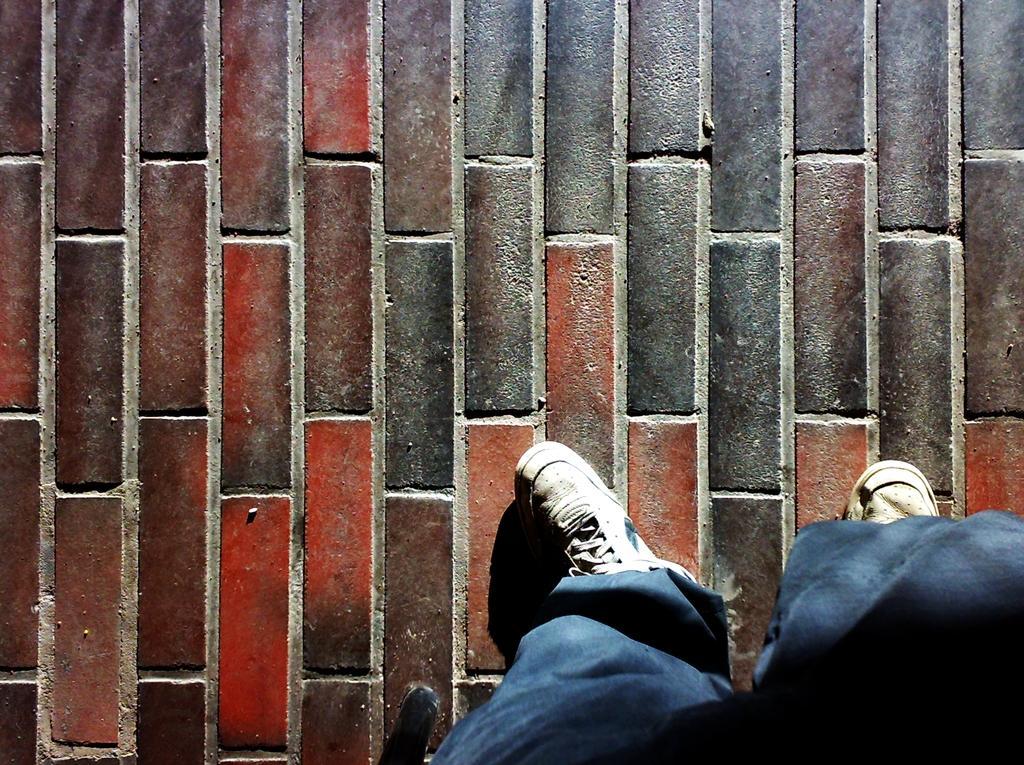Could you give a brief overview of what you see in this image? In this image we can see the brick floor. And we can see the human legs. 